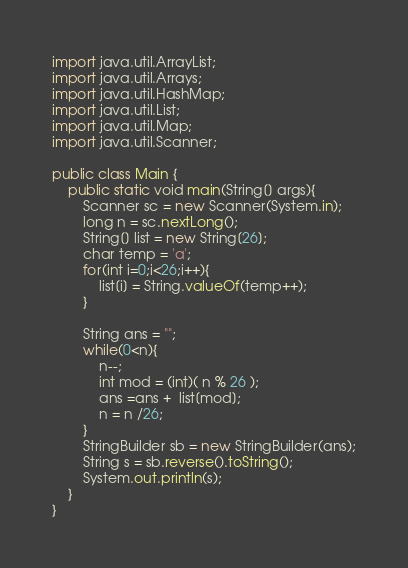<code> <loc_0><loc_0><loc_500><loc_500><_Java_>
import java.util.ArrayList;
import java.util.Arrays;
import java.util.HashMap;
import java.util.List;
import java.util.Map;
import java.util.Scanner;
 
public class Main {    
    public static void main(String[] args){
        Scanner sc = new Scanner(System.in);
        long n = sc.nextLong();
        String[] list = new String[26];
        char temp = 'a';
        for(int i=0;i<26;i++){
            list[i] = String.valueOf(temp++);
        }

        String ans = "";
        while(0<n){
            n--;
            int mod = (int)( n % 26 );
            ans =ans +  list[mod];
            n = n /26;
        }
        StringBuilder sb = new StringBuilder(ans);
        String s = sb.reverse().toString();
        System.out.println(s);
    }
}</code> 